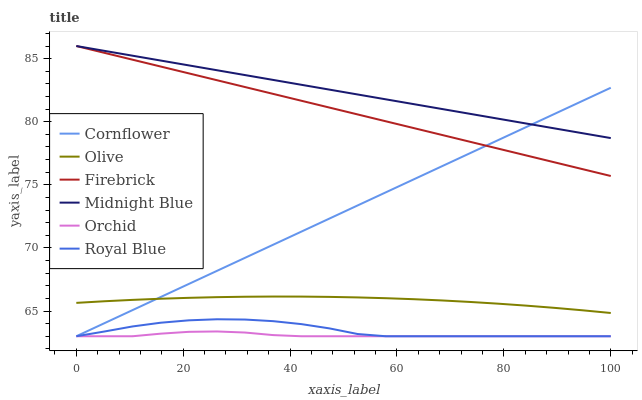Does Orchid have the minimum area under the curve?
Answer yes or no. Yes. Does Midnight Blue have the maximum area under the curve?
Answer yes or no. Yes. Does Firebrick have the minimum area under the curve?
Answer yes or no. No. Does Firebrick have the maximum area under the curve?
Answer yes or no. No. Is Cornflower the smoothest?
Answer yes or no. Yes. Is Royal Blue the roughest?
Answer yes or no. Yes. Is Midnight Blue the smoothest?
Answer yes or no. No. Is Midnight Blue the roughest?
Answer yes or no. No. Does Cornflower have the lowest value?
Answer yes or no. Yes. Does Firebrick have the lowest value?
Answer yes or no. No. Does Firebrick have the highest value?
Answer yes or no. Yes. Does Royal Blue have the highest value?
Answer yes or no. No. Is Orchid less than Firebrick?
Answer yes or no. Yes. Is Firebrick greater than Orchid?
Answer yes or no. Yes. Does Cornflower intersect Firebrick?
Answer yes or no. Yes. Is Cornflower less than Firebrick?
Answer yes or no. No. Is Cornflower greater than Firebrick?
Answer yes or no. No. Does Orchid intersect Firebrick?
Answer yes or no. No. 